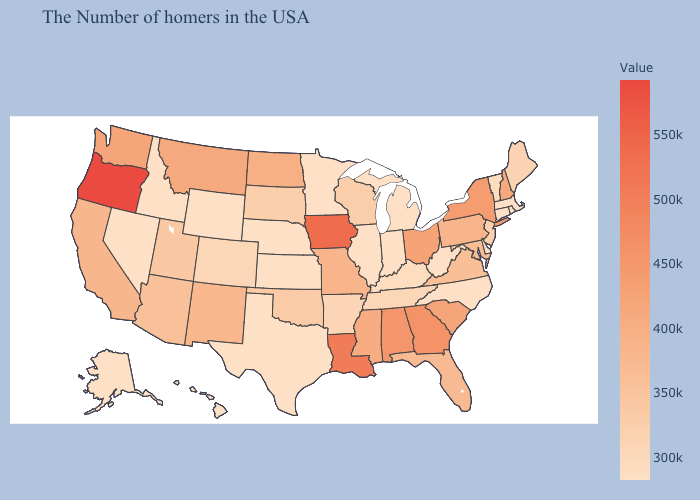Among the states that border Kansas , does Colorado have the lowest value?
Answer briefly. No. Among the states that border Utah , which have the lowest value?
Be succinct. Wyoming, Idaho, Nevada. Among the states that border Alabama , which have the lowest value?
Quick response, please. Tennessee. Does New York have the highest value in the Northeast?
Be succinct. Yes. Which states have the lowest value in the Northeast?
Quick response, please. Massachusetts, Rhode Island, Connecticut. 